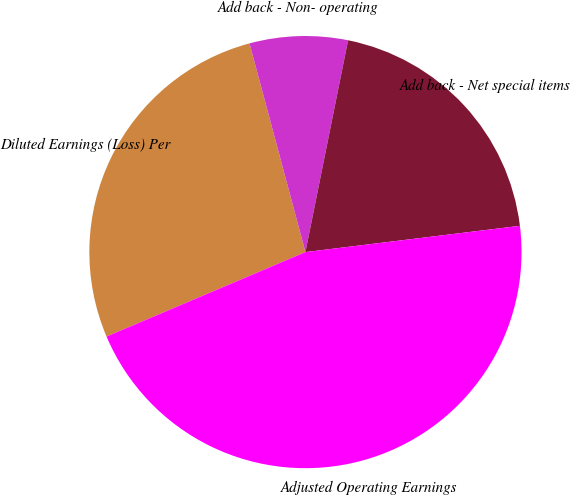Convert chart. <chart><loc_0><loc_0><loc_500><loc_500><pie_chart><fcel>Diluted Earnings (Loss) Per<fcel>Add back - Non- operating<fcel>Add back - Net special items<fcel>Adjusted Operating Earnings<nl><fcel>27.23%<fcel>7.33%<fcel>19.9%<fcel>45.55%<nl></chart> 